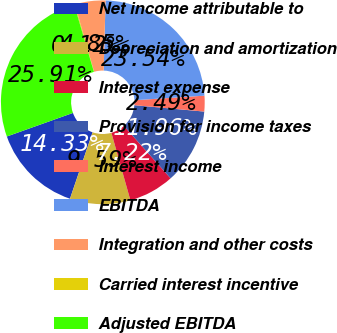<chart> <loc_0><loc_0><loc_500><loc_500><pie_chart><fcel>Net income attributable to<fcel>Depreciation and amortization<fcel>Interest expense<fcel>Provision for income taxes<fcel>Interest income<fcel>EBITDA<fcel>Integration and other costs<fcel>Carried interest incentive<fcel>Adjusted EBITDA<nl><fcel>14.33%<fcel>9.59%<fcel>7.22%<fcel>11.96%<fcel>2.49%<fcel>23.54%<fcel>4.85%<fcel>0.12%<fcel>25.91%<nl></chart> 